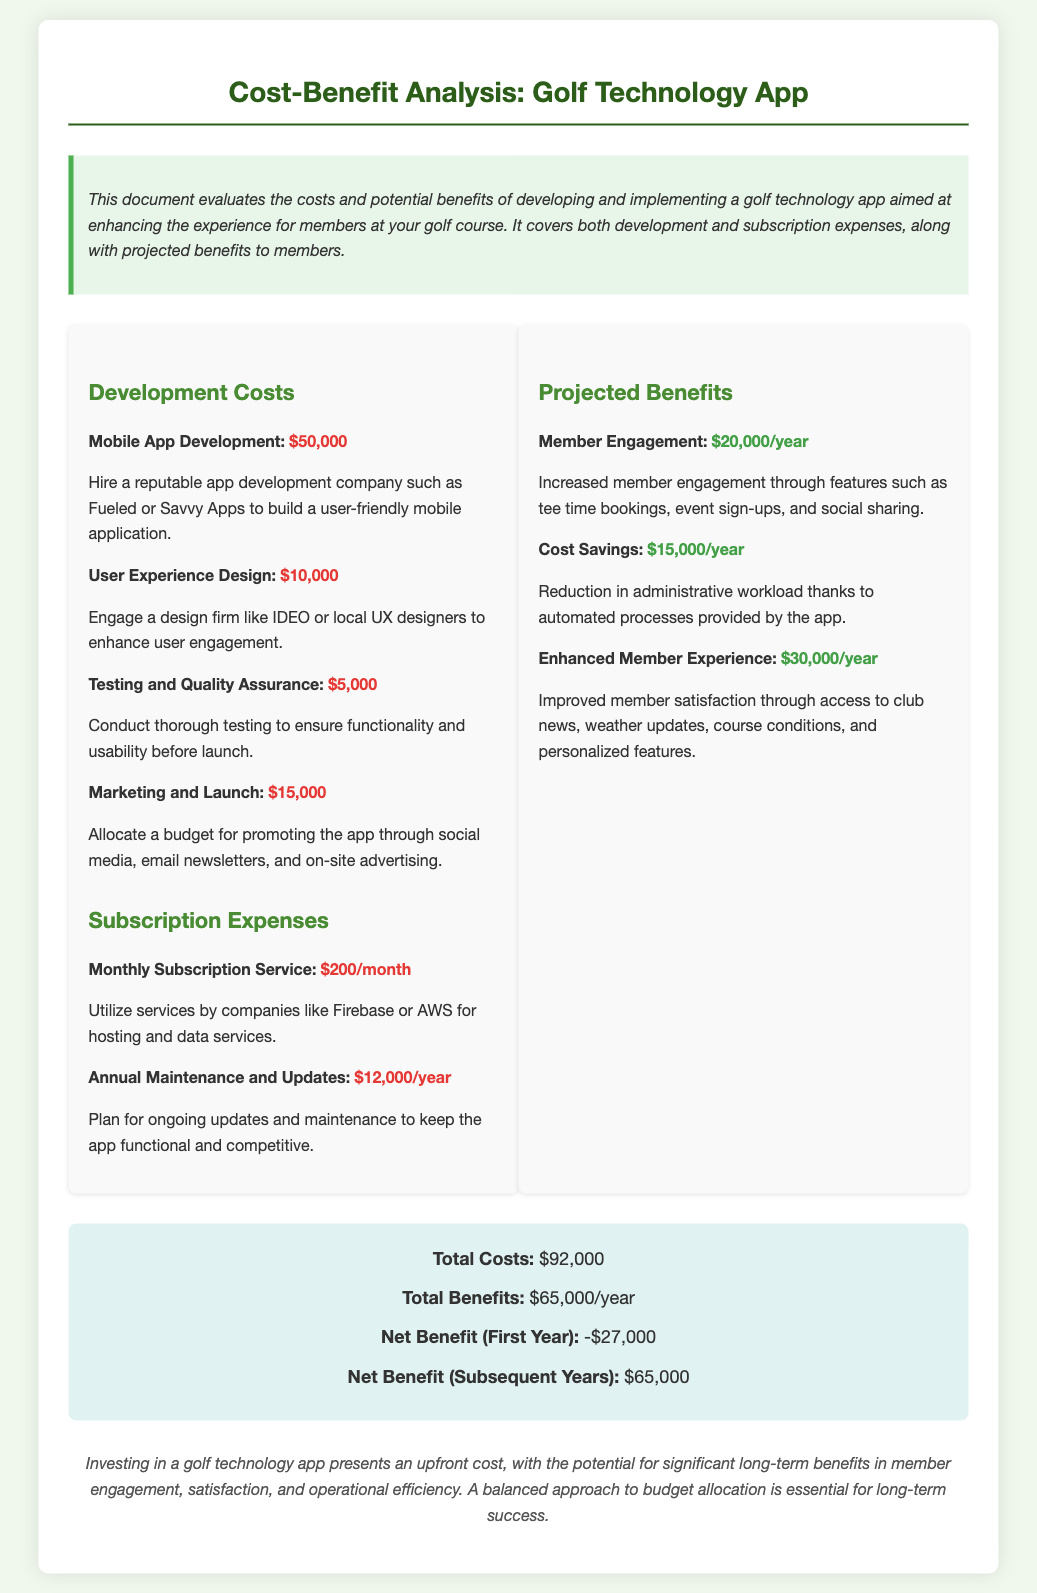What is the total cost? The total cost is presented under the total section of the document, which aggregates all development and subscription expenses.
Answer: $92,000 What is the monthly subscription service cost? The monthly subscription service cost is detailed in the subscription expenses section of the document.
Answer: $200/month What is the annual maintenance and updates cost? The cost for annual maintenance and updates is listed in the subscription expenses section.
Answer: $12,000/year Who are suggested firms for app development? The document suggests reputable app development companies, which provides information about where to source the development.
Answer: Fueled or Savvy Apps What is the projected benefit of member engagement? The projected benefit associated with member engagement is found under the projected benefits section.
Answer: $20,000/year What is the net benefit in the first year? The net benefit in the first year is calculated by contrasting total costs with total benefits in the summary.
Answer: -$27,000 What is the primary goal of the technology app? The document outlines the primary aim of the app in the executive summary.
Answer: Enhancing the experience for members What are the potential brand benefits mentioned? Potential brand benefits include improved member satisfaction and engagement from the app features.
Answer: Enhanced Member Experience What aspect of the app could lead to operational savings? The document cites specific automated processes that could reduce administrative workload as a source of operational savings.
Answer: Cost Savings 